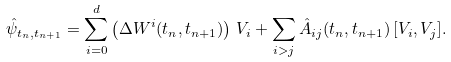Convert formula to latex. <formula><loc_0><loc_0><loc_500><loc_500>\hat { \psi } _ { t _ { n } , t _ { n + 1 } } = \sum _ { i = 0 } ^ { d } \left ( \Delta W ^ { i } ( t _ { n } , t _ { n + 1 } ) \right ) \, V _ { i } + \sum _ { i > j } \hat { A } _ { i j } ( t _ { n } , t _ { n + 1 } ) \, [ V _ { i } , V _ { j } ] .</formula> 